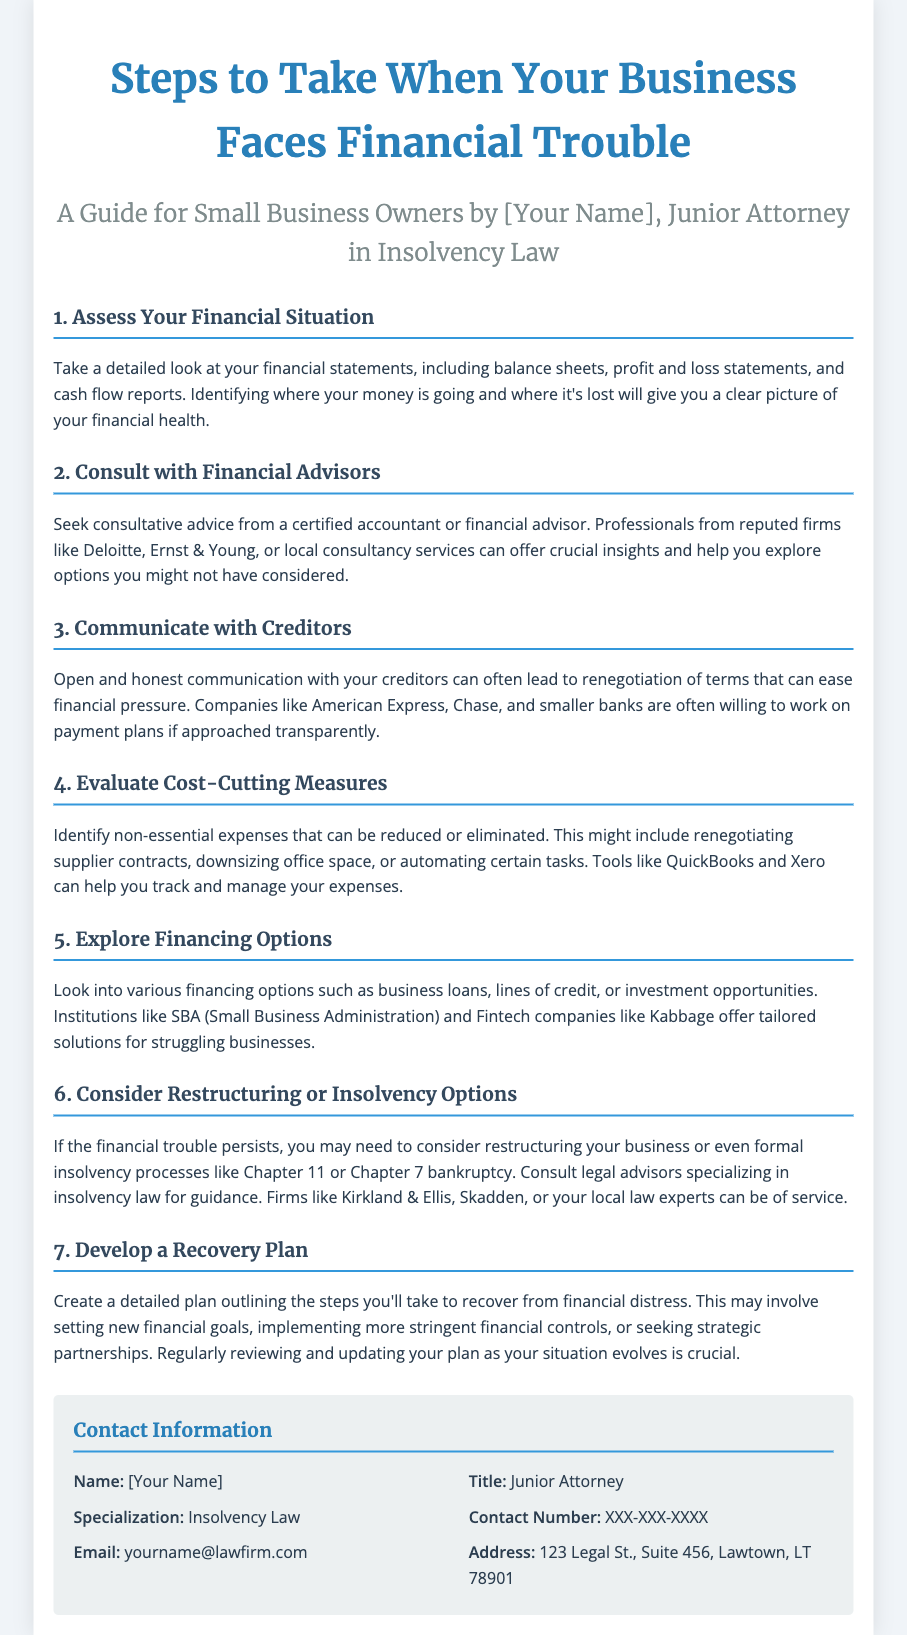What is the title of the document? The title of the document is indicated at the top in a larger font.
Answer: Steps to Take When Your Business Faces Financial Trouble Who is the author of the document? The author's name is stated in the subtitle of the document.
Answer: [Your Name] What is the first step to take when facing financial trouble? The first step is listed as the first section of the document.
Answer: Assess Your Financial Situation Which professional should you consult for advice? The document suggests consulting a specific type of professional for financial advice.
Answer: Financial Advisors What should you develop after evaluating your financial situation? This is outlined as an important step towards recovery mentioned towards the end of the document.
Answer: Recovery Plan Name one financing option mentioned in the document. The financing options listed in one of the sections can be excerpted directly from the content.
Answer: Business loans Which law firms are suggested for advising on insolvency options? The names of specific law firms are mentioned in the section about restructuring or insolvency options.
Answer: Kirkland & Ellis, Skadden How many steps are outlined in the document? The number of steps can be derived from the content structure of the document.
Answer: Seven steps 